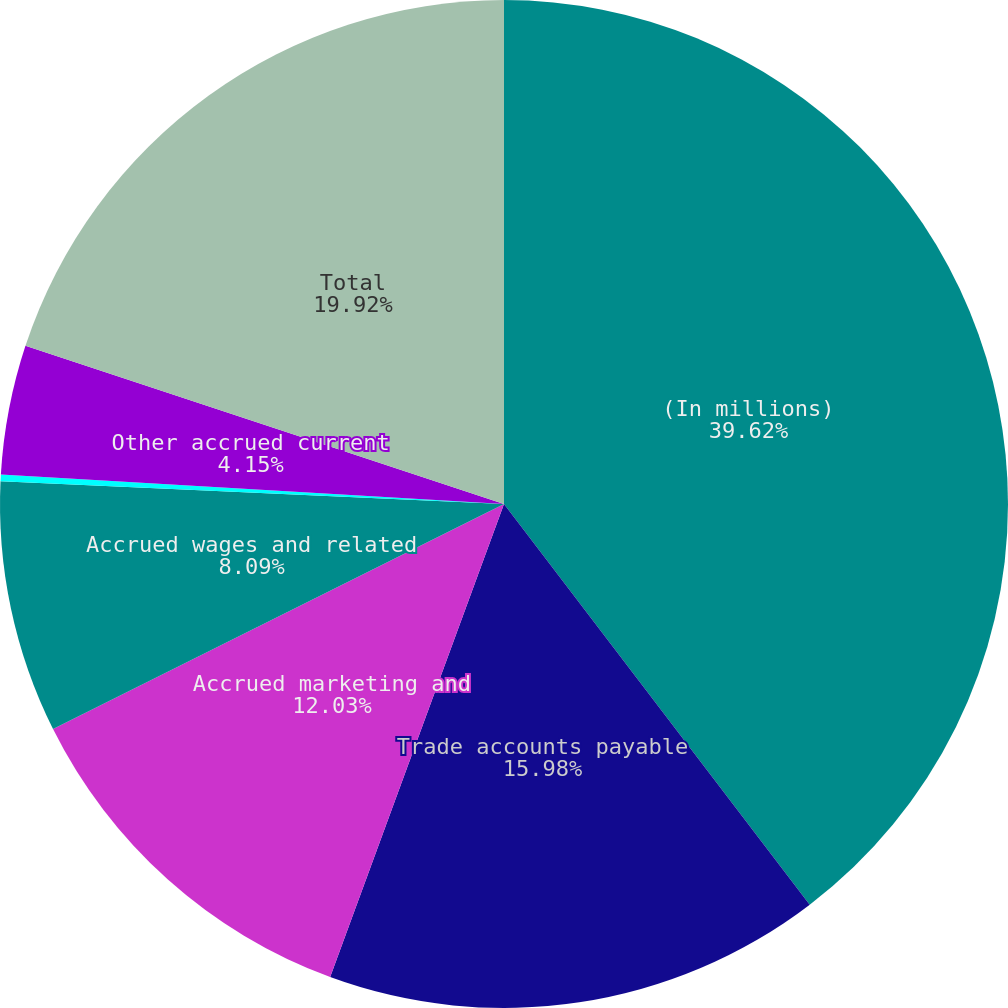Convert chart to OTSL. <chart><loc_0><loc_0><loc_500><loc_500><pie_chart><fcel>(In millions)<fcel>Trade accounts payable<fcel>Accrued marketing and<fcel>Accrued wages and related<fcel>Accrued profit sharing<fcel>Other accrued current<fcel>Total<nl><fcel>39.63%<fcel>15.98%<fcel>12.03%<fcel>8.09%<fcel>0.21%<fcel>4.15%<fcel>19.92%<nl></chart> 